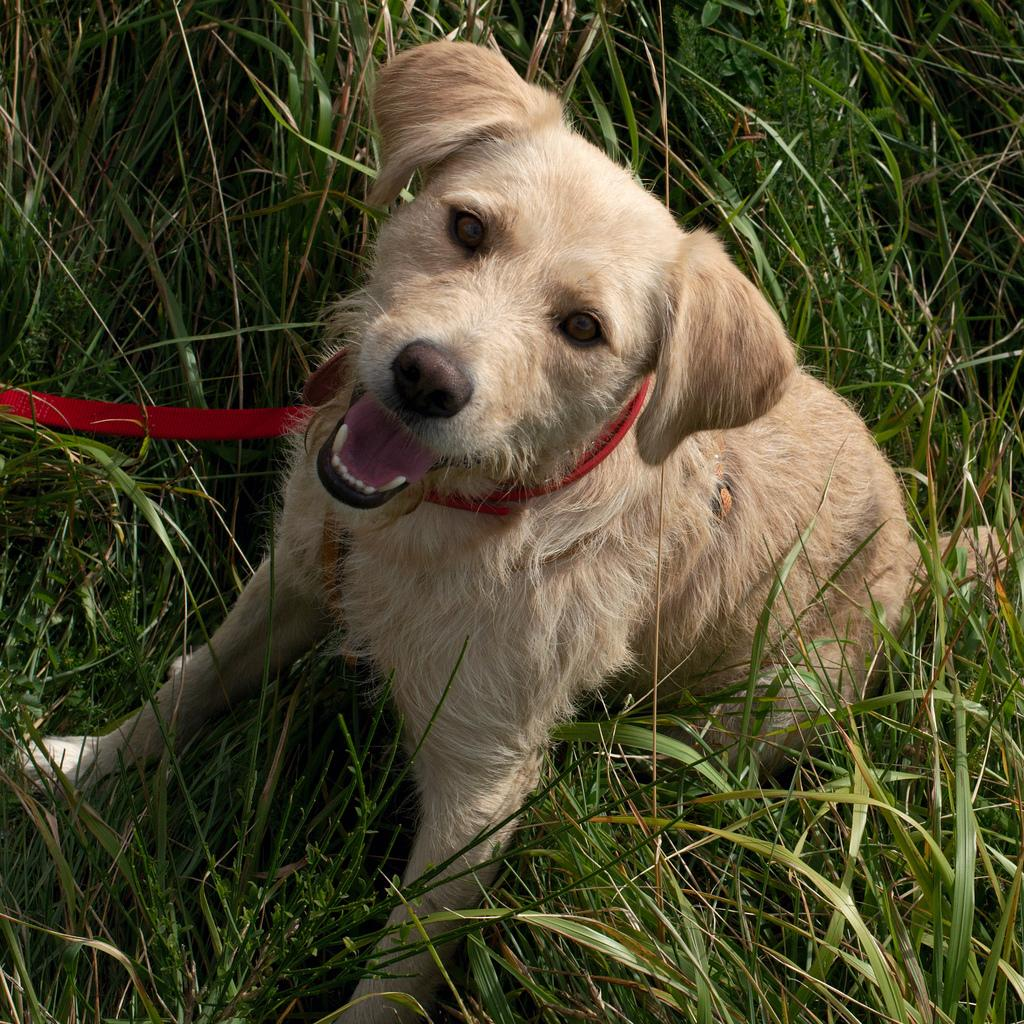What type of animal is in the image? There is a brown color dog in the image. Where is the dog located? The dog is sitting on the grass. What is the dog doing in the image? The dog is looking into the camera. What type of observation can be made about the cub in the image? There is no cub present in the image; it features a brown color dog. 